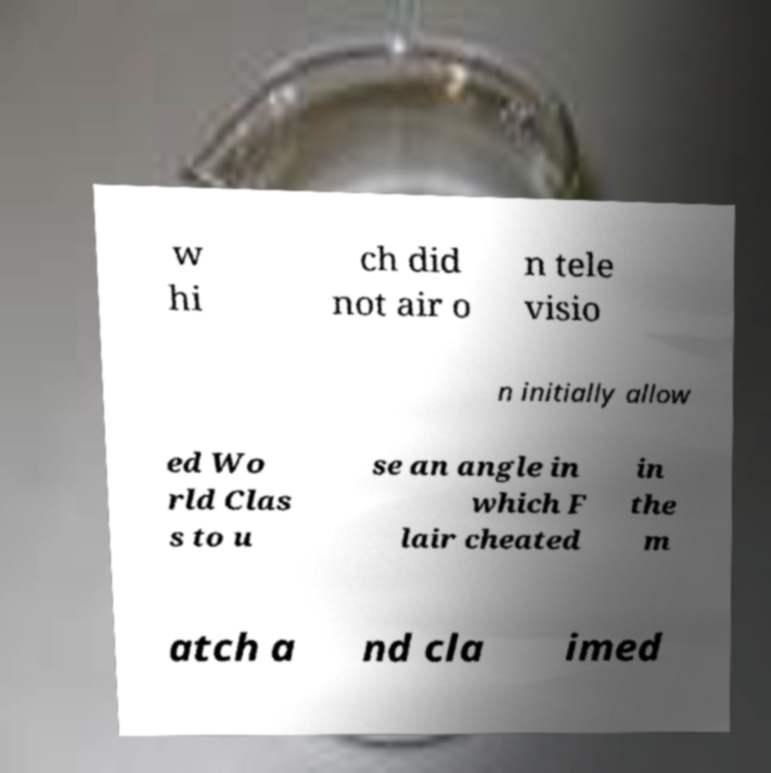Please identify and transcribe the text found in this image. w hi ch did not air o n tele visio n initially allow ed Wo rld Clas s to u se an angle in which F lair cheated in the m atch a nd cla imed 